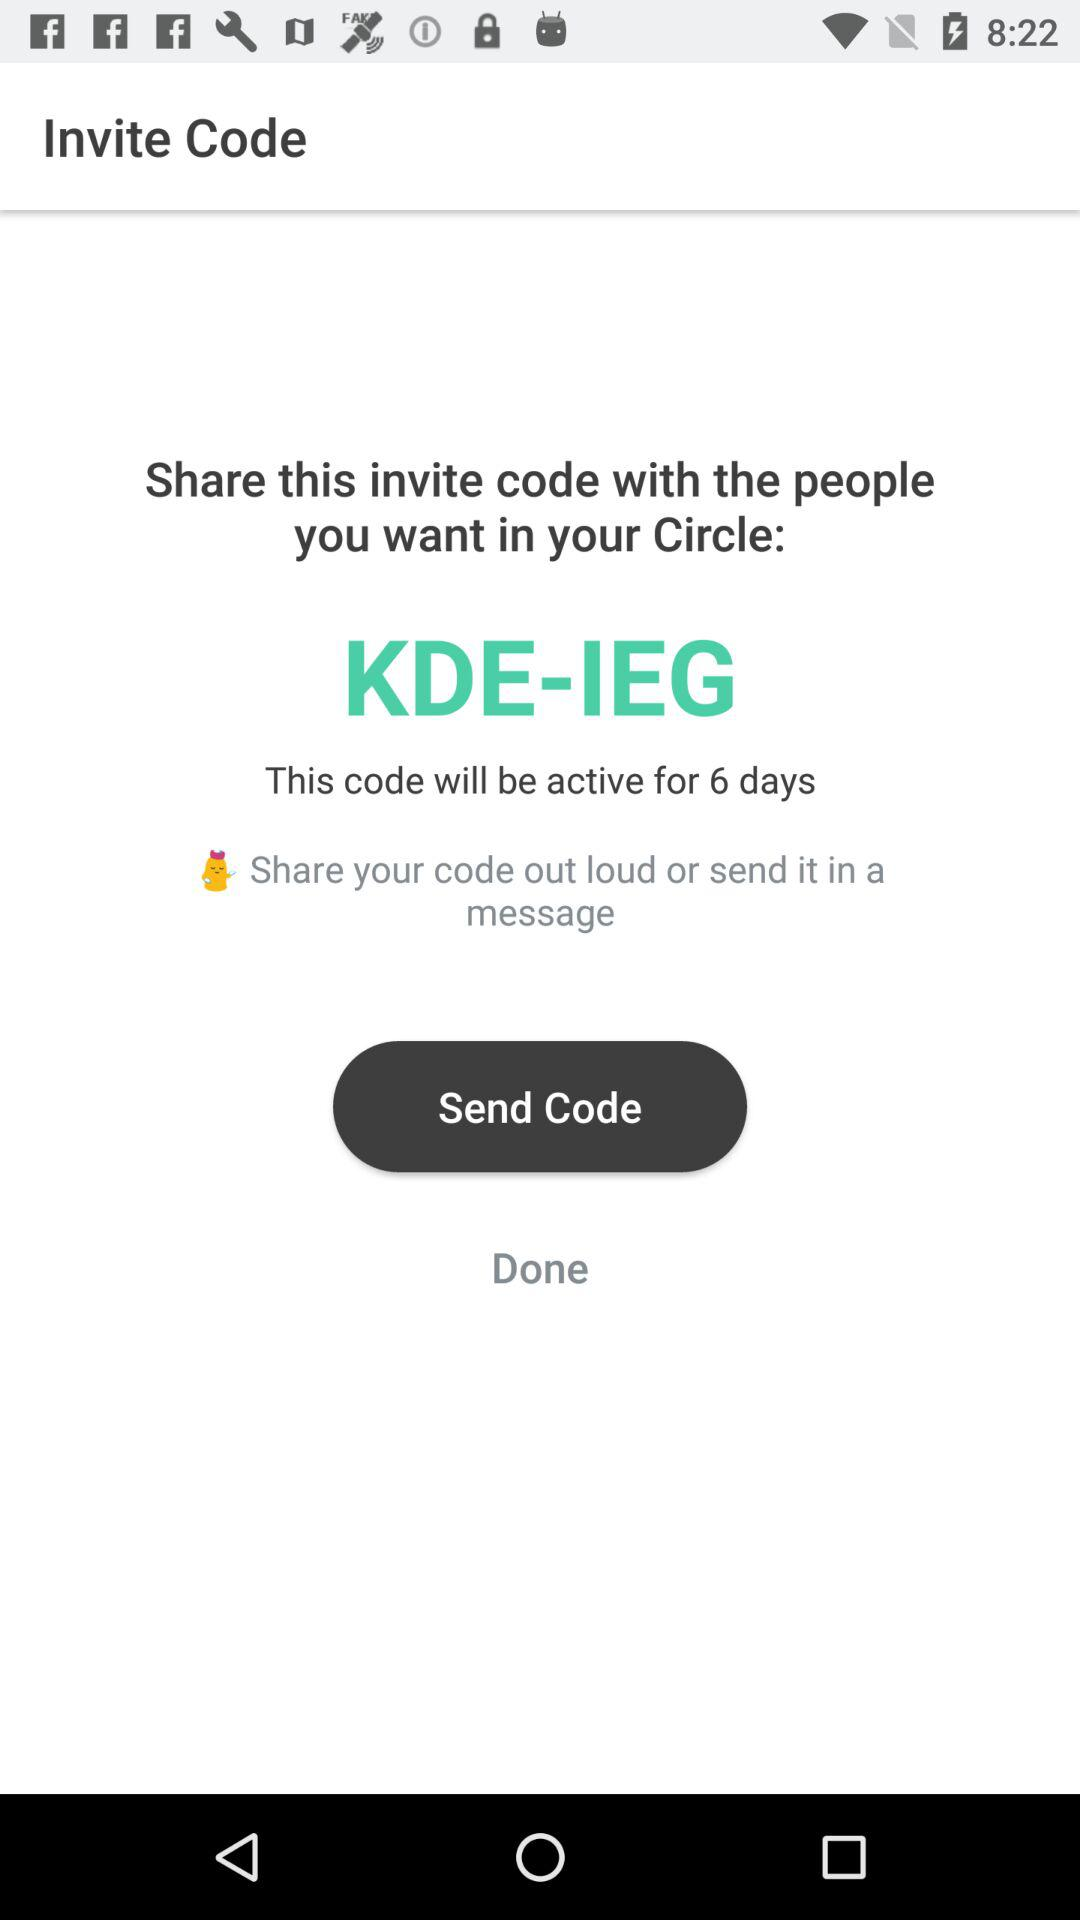What's the code? The code is "KDE-IEG". 